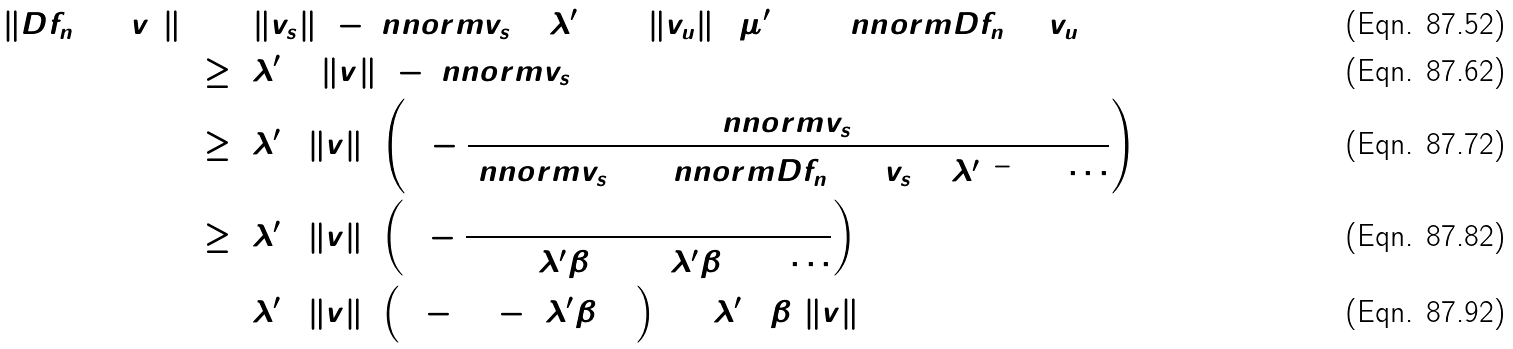Convert formula to latex. <formula><loc_0><loc_0><loc_500><loc_500>\| D f _ { n } ( 0 ) ( v ) \| ^ { 2 } & = ( \| v _ { s } \| ^ { 2 } - \ n n o r m { v _ { s } } ^ { 2 } ) ( \lambda ^ { \prime } ) ^ { 2 } + \| v _ { u } \| ^ { 2 } ( \mu ^ { \prime } ) ^ { 2 } + \ n n o r m { D f _ { n } ( 0 ) v _ { u } } \\ & \geq ( \lambda ^ { \prime } ) ^ { 2 } ( \| v \| ^ { 2 } - \ n n o r m { v _ { s } } ^ { 2 } ) \\ & \geq ( \lambda ^ { \prime } ) ^ { 2 } \| v \| ^ { 2 } \left ( 1 - \frac { \ n n o r m { v _ { s } } ^ { 2 } } { \ n n o r m { v _ { s } } ^ { 2 } + \ n n o r m { D f _ { n } ( 0 ) ( v _ { s } ) } ^ { 2 } ( \lambda ^ { \prime } ) ^ { - 2 } + \cdots } \right ) \\ & \geq ( \lambda ^ { \prime } ) ^ { 2 } \| v \| ^ { 2 } \left ( 1 - \frac { 1 } { 1 + ( \lambda ^ { \prime } \hat { \beta } ) ^ { 2 } + ( \lambda ^ { \prime } \hat { \beta } ) ^ { 4 } + \cdots } \right ) \\ & = ( \lambda ^ { \prime } ) ^ { 2 } \| v \| ^ { 2 } \left ( 1 - ( 1 - ( \lambda ^ { \prime } \hat { \beta } ) ^ { 2 } ) \right ) = ( \lambda ^ { \prime } ) ^ { 4 } \hat { \beta } ^ { 2 } \| v \| ^ { 2 }</formula> 